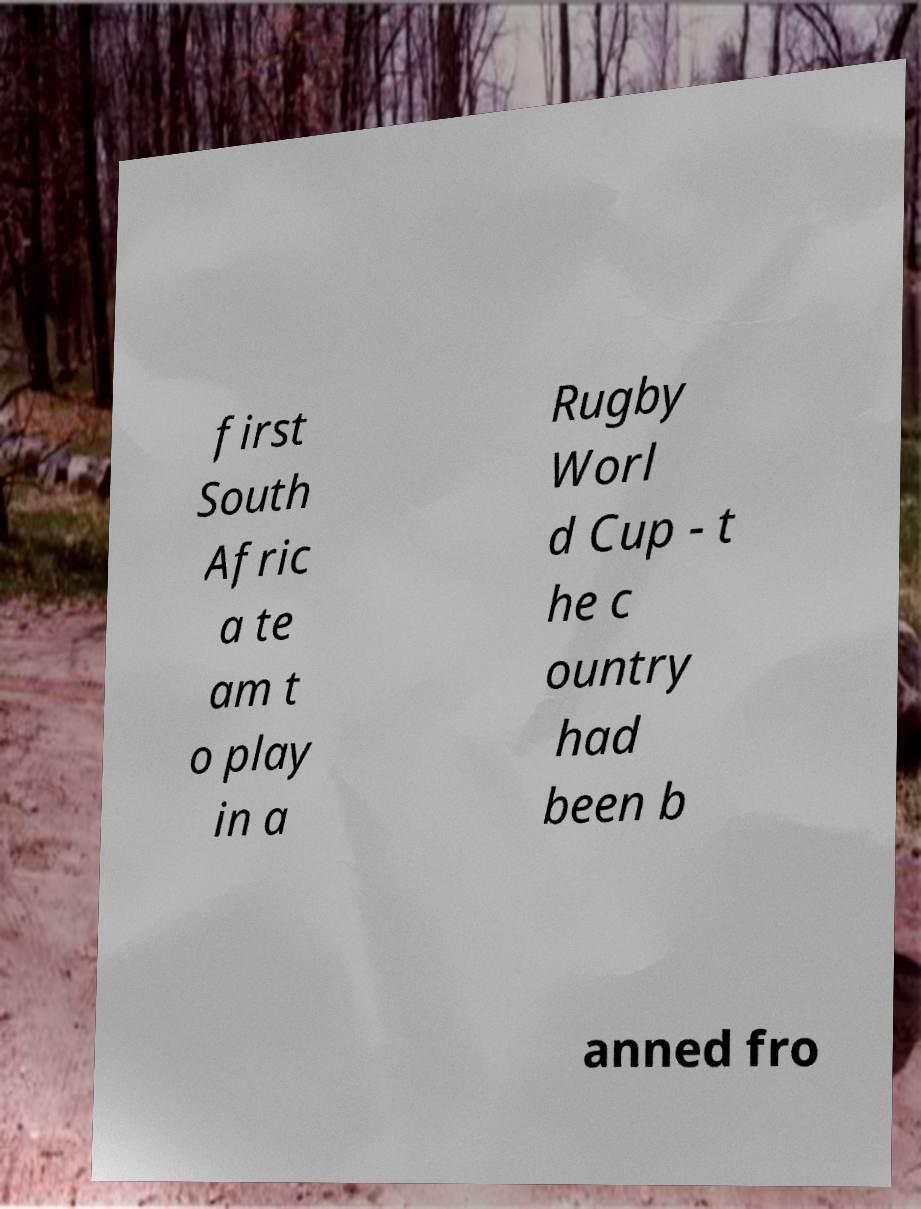Please identify and transcribe the text found in this image. first South Afric a te am t o play in a Rugby Worl d Cup - t he c ountry had been b anned fro 